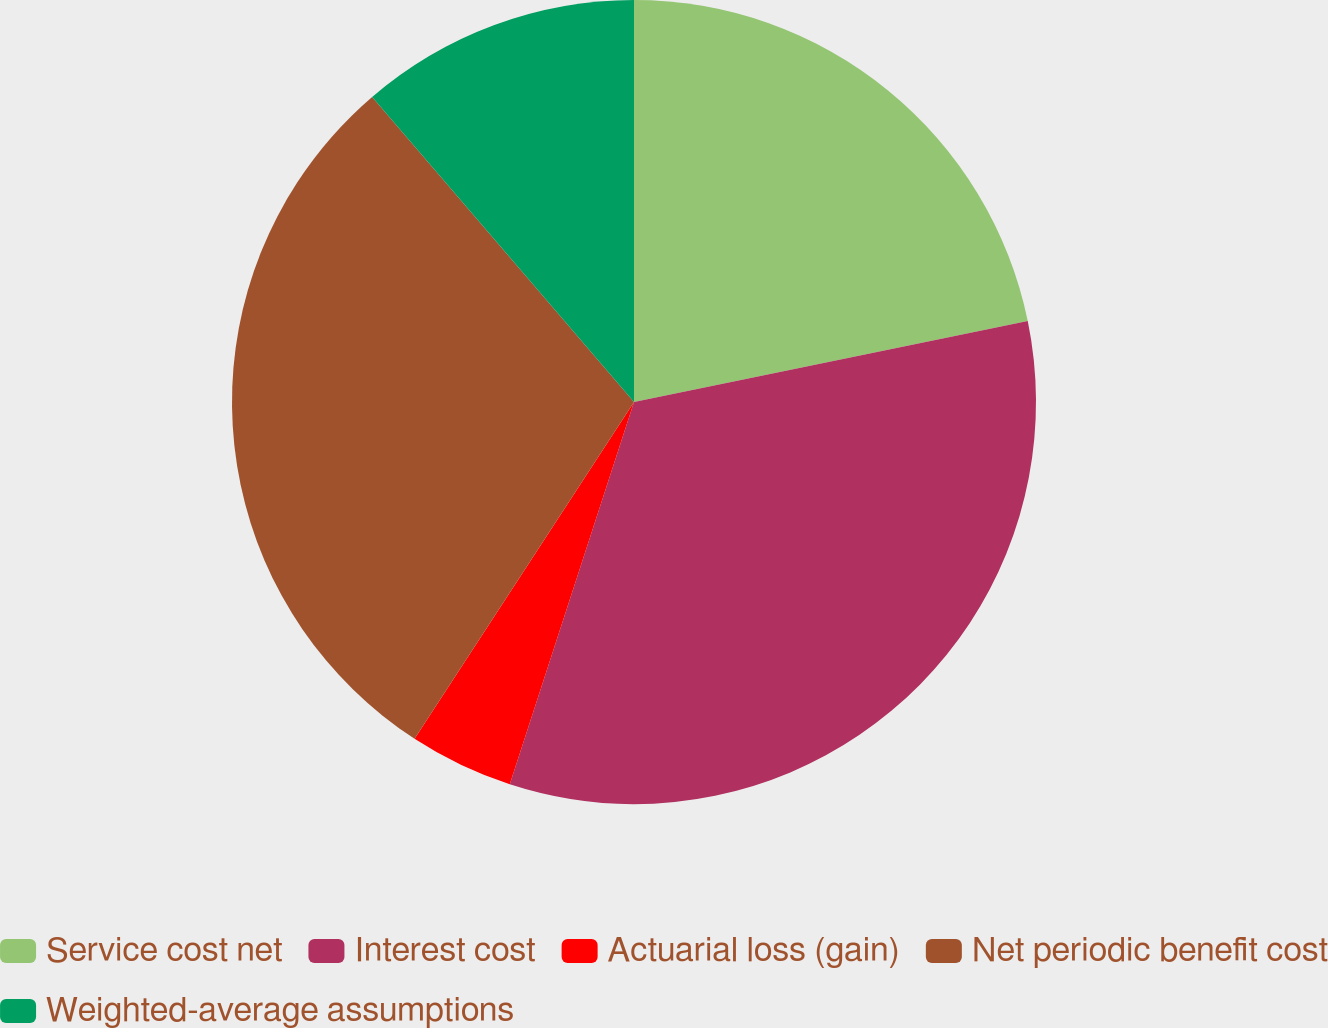Convert chart to OTSL. <chart><loc_0><loc_0><loc_500><loc_500><pie_chart><fcel>Service cost net<fcel>Interest cost<fcel>Actuarial loss (gain)<fcel>Net periodic benefit cost<fcel>Weighted-average assumptions<nl><fcel>21.77%<fcel>33.23%<fcel>4.19%<fcel>29.52%<fcel>11.29%<nl></chart> 